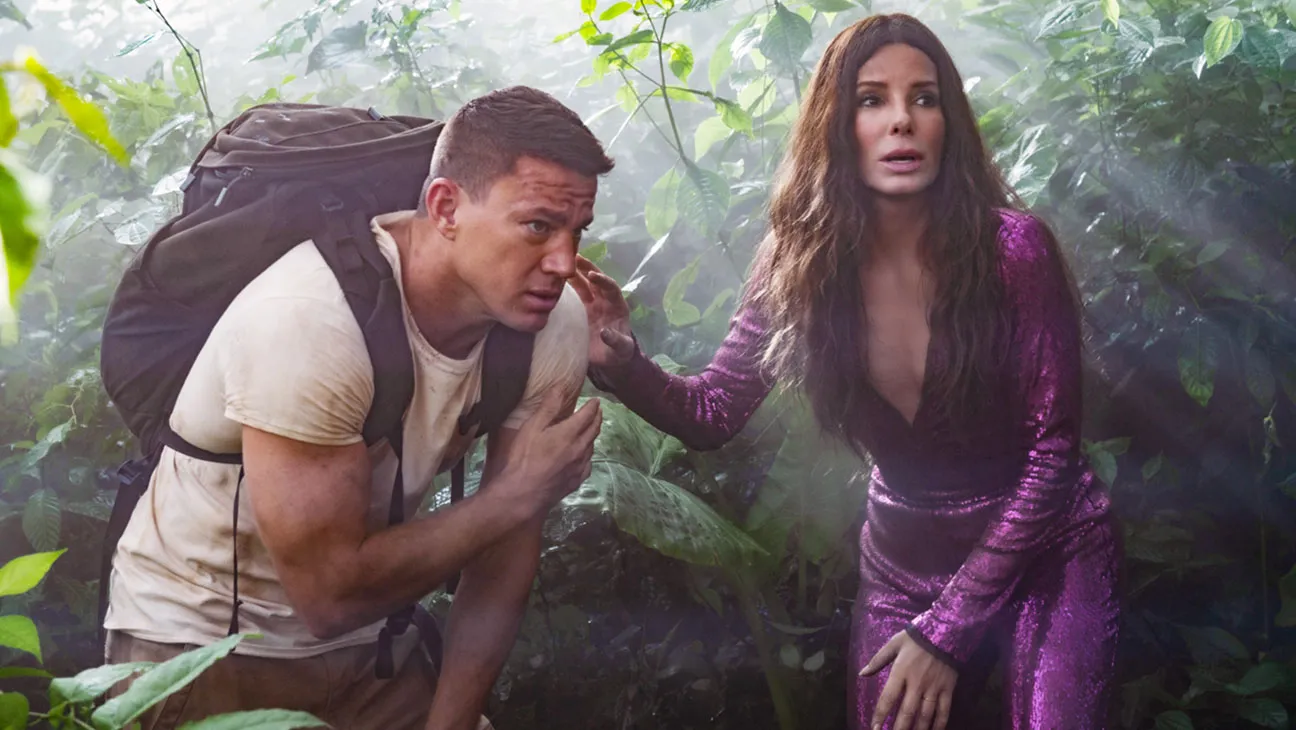What themes from the movie are captured in this particular image? This image encapsulates themes of adventure, exploration, and the clash between civilization and nature. It also touches on themes of survival and romance under stressful conditions. The juxtaposition of their attire against the wild, overgrown jungle adds a layer of visual irony that enhances these themes, making a statement about the unpredictability of their journey. 